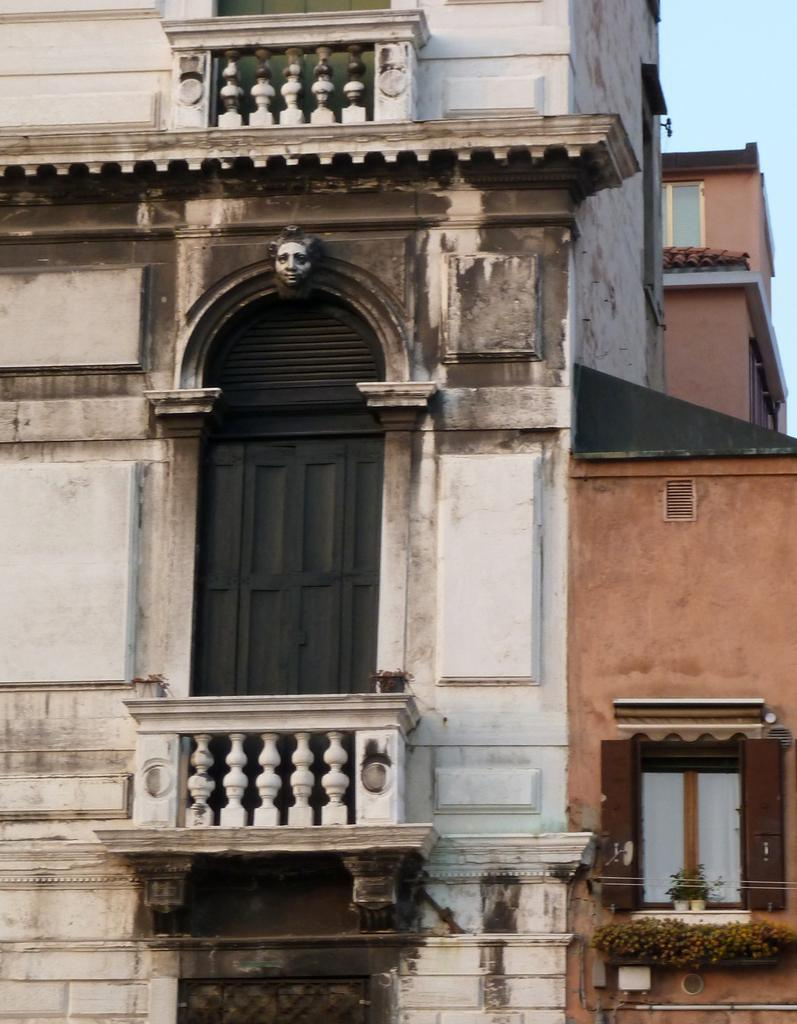What type of building is in the picture? There is a house in the picture. What part of the house can be used for entering or exiting? There is a door in the picture. What part of the house can be used for viewing the outside or allowing natural light to enter? There is a window in the picture. What type of reaction can be seen from the house in the image? There is no reaction from the house in the image, as it is an inanimate object. 